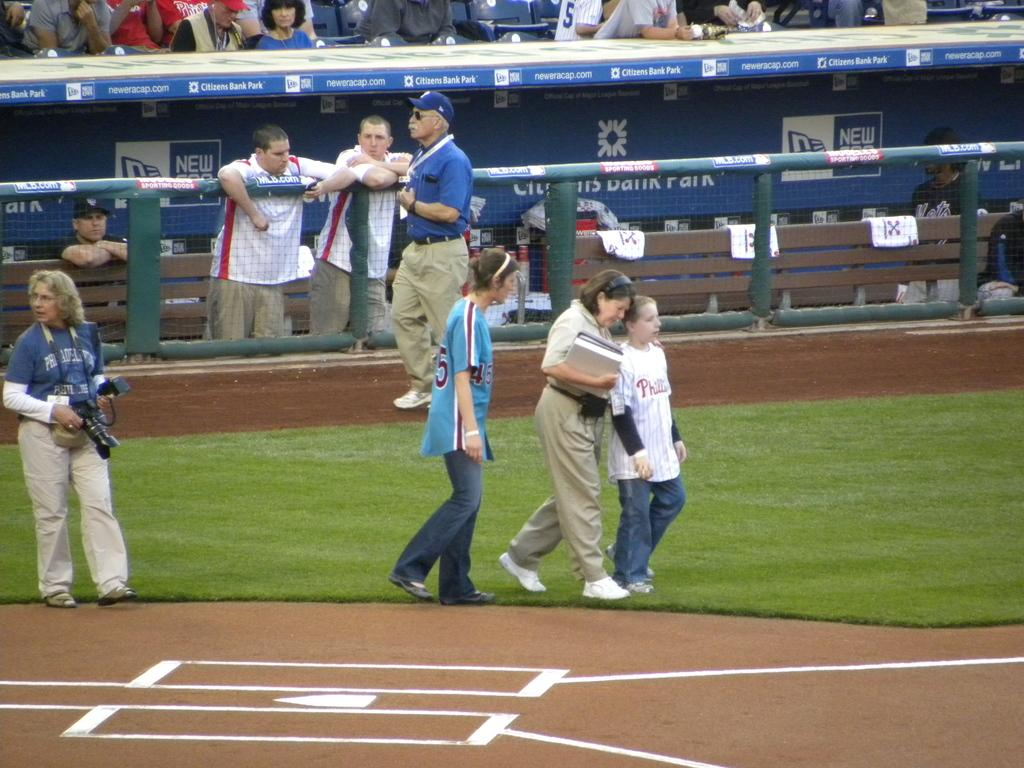<image>
Render a clear and concise summary of the photo. a teen philly baseball player on the field with a reporter 